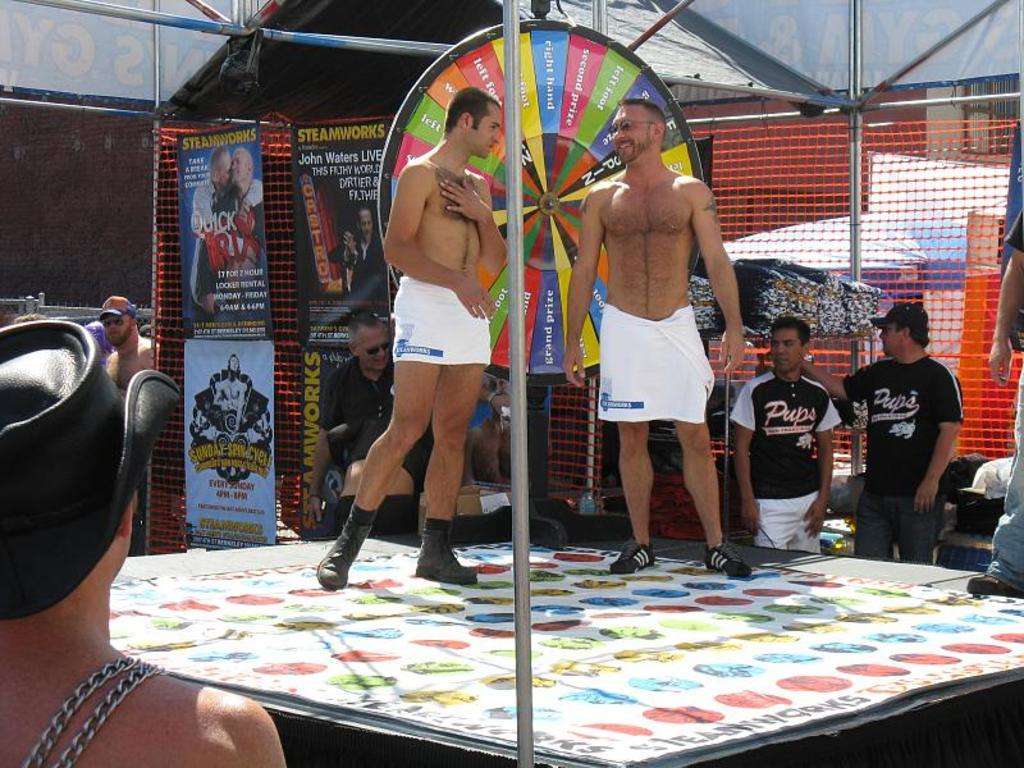<image>
Write a terse but informative summary of the picture. Men wearing a jersey that reads Pups stand in the background. 